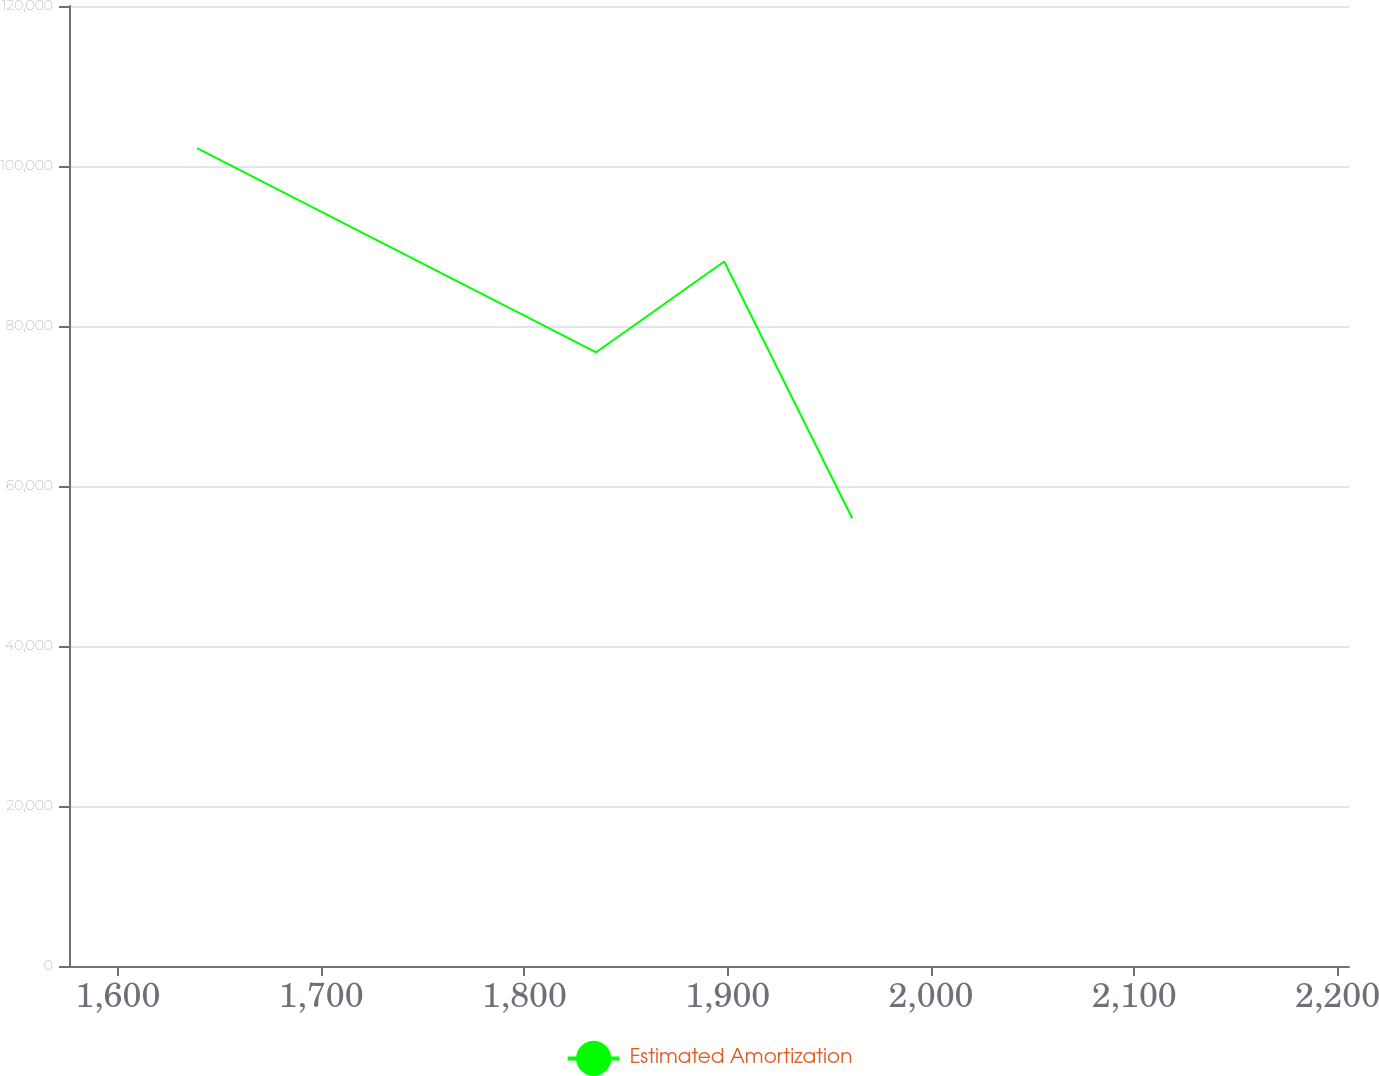Convert chart to OTSL. <chart><loc_0><loc_0><loc_500><loc_500><line_chart><ecel><fcel>Estimated Amortization<nl><fcel>1638.96<fcel>102244<nl><fcel>1835.33<fcel>76716.4<nl><fcel>1898.3<fcel>88064.7<nl><fcel>1961.27<fcel>55963.2<nl><fcel>2268.62<fcel>49501.7<nl></chart> 